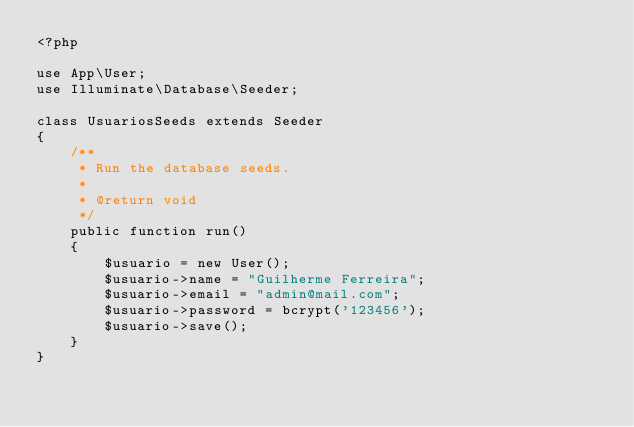Convert code to text. <code><loc_0><loc_0><loc_500><loc_500><_PHP_><?php

use App\User;
use Illuminate\Database\Seeder;

class UsuariosSeeds extends Seeder
{
    /**
     * Run the database seeds.
     *
     * @return void
     */
    public function run()
    {
        $usuario = new User();
        $usuario->name = "Guilherme Ferreira";
        $usuario->email = "admin@mail.com";
        $usuario->password = bcrypt('123456');
        $usuario->save();
    }
}

</code> 